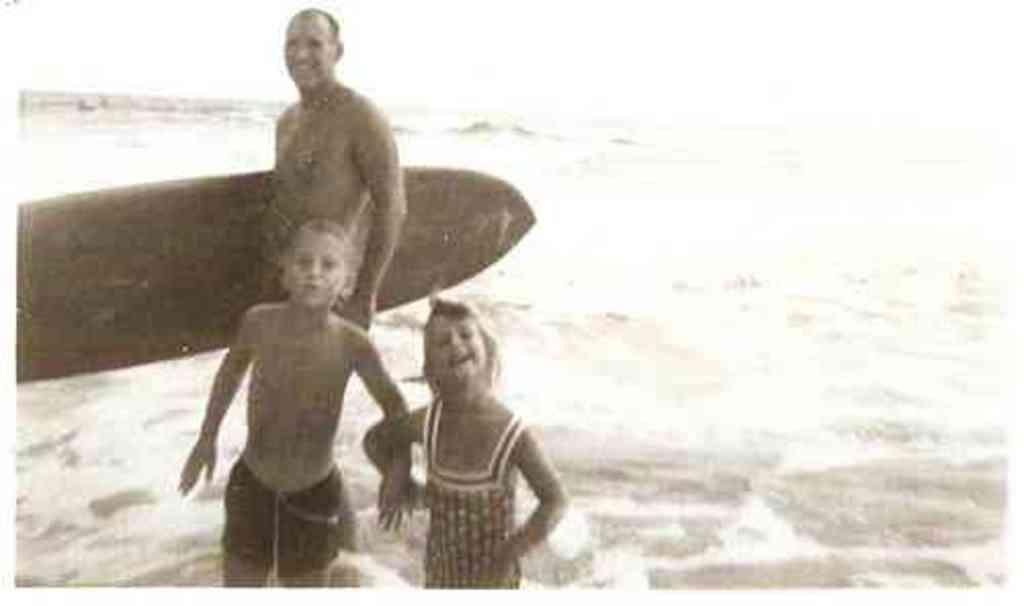How many people are in the image? There are three people in the image. What are the people doing in the image? The people are standing in water. Can you describe any objects being held by the people? One man is holding a surfboard. How many cats can be seen playing with a club in the image? There are no cats or clubs present in the image. 